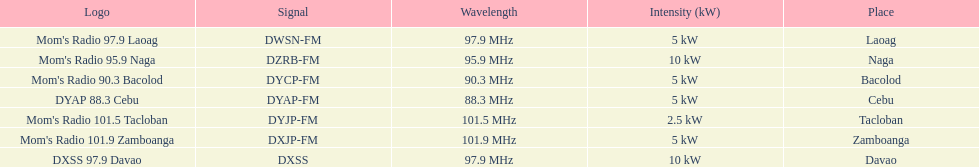What is the radio with the least about of mhz? DYAP 88.3 Cebu. 